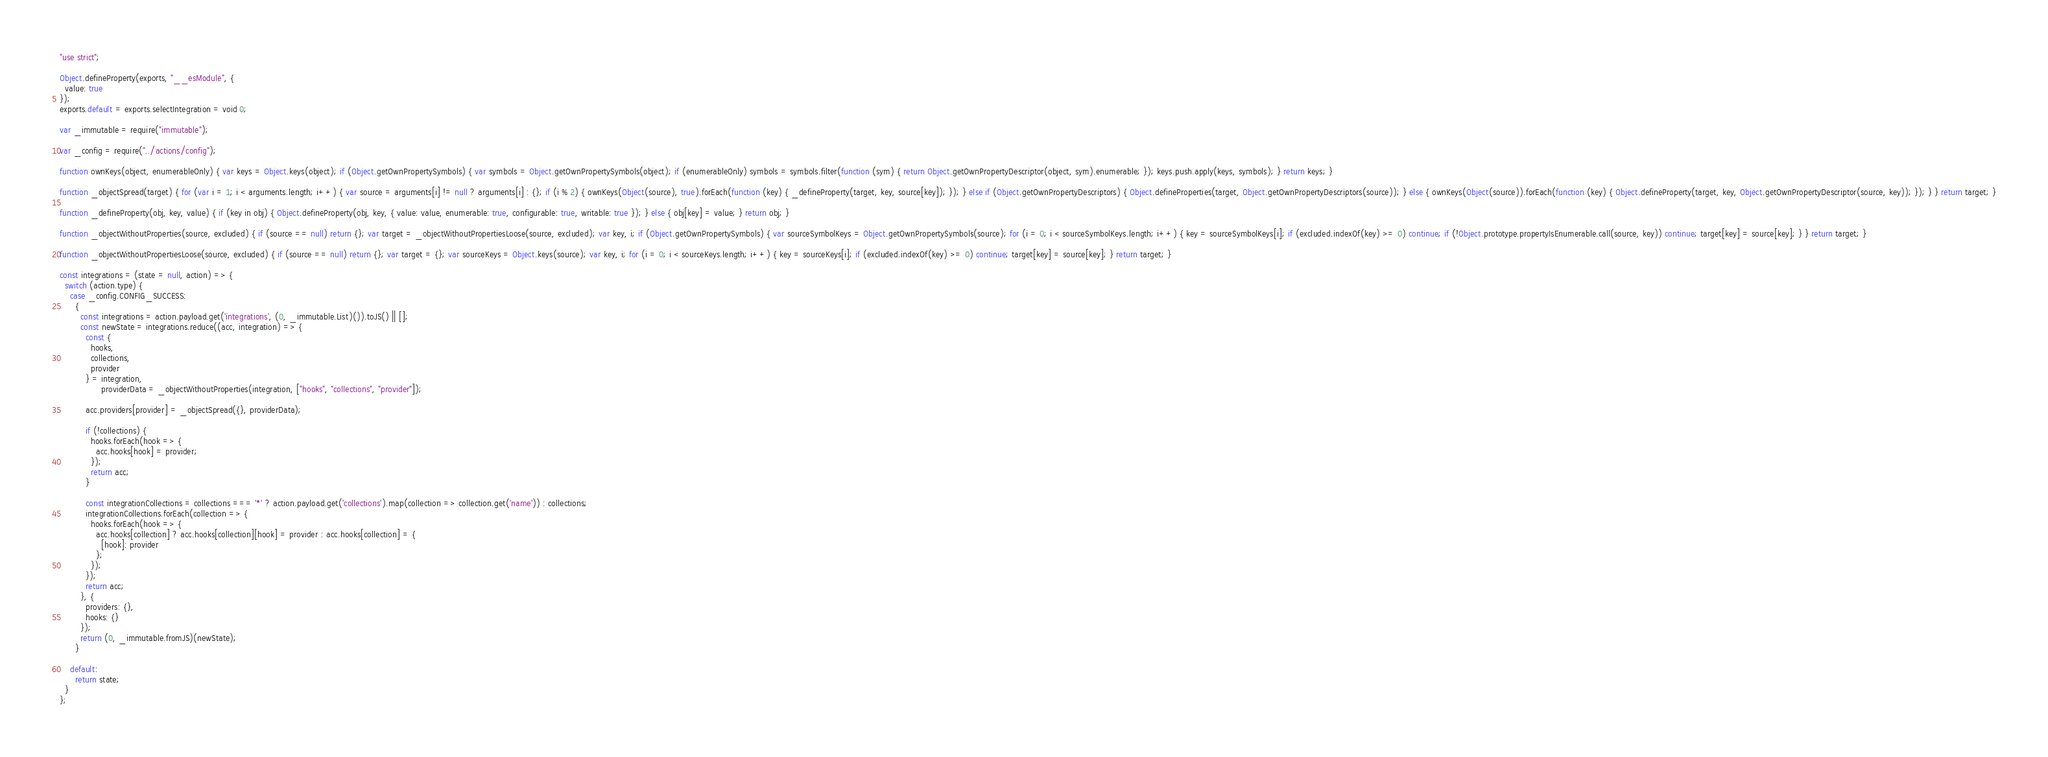<code> <loc_0><loc_0><loc_500><loc_500><_JavaScript_>"use strict";

Object.defineProperty(exports, "__esModule", {
  value: true
});
exports.default = exports.selectIntegration = void 0;

var _immutable = require("immutable");

var _config = require("../actions/config");

function ownKeys(object, enumerableOnly) { var keys = Object.keys(object); if (Object.getOwnPropertySymbols) { var symbols = Object.getOwnPropertySymbols(object); if (enumerableOnly) symbols = symbols.filter(function (sym) { return Object.getOwnPropertyDescriptor(object, sym).enumerable; }); keys.push.apply(keys, symbols); } return keys; }

function _objectSpread(target) { for (var i = 1; i < arguments.length; i++) { var source = arguments[i] != null ? arguments[i] : {}; if (i % 2) { ownKeys(Object(source), true).forEach(function (key) { _defineProperty(target, key, source[key]); }); } else if (Object.getOwnPropertyDescriptors) { Object.defineProperties(target, Object.getOwnPropertyDescriptors(source)); } else { ownKeys(Object(source)).forEach(function (key) { Object.defineProperty(target, key, Object.getOwnPropertyDescriptor(source, key)); }); } } return target; }

function _defineProperty(obj, key, value) { if (key in obj) { Object.defineProperty(obj, key, { value: value, enumerable: true, configurable: true, writable: true }); } else { obj[key] = value; } return obj; }

function _objectWithoutProperties(source, excluded) { if (source == null) return {}; var target = _objectWithoutPropertiesLoose(source, excluded); var key, i; if (Object.getOwnPropertySymbols) { var sourceSymbolKeys = Object.getOwnPropertySymbols(source); for (i = 0; i < sourceSymbolKeys.length; i++) { key = sourceSymbolKeys[i]; if (excluded.indexOf(key) >= 0) continue; if (!Object.prototype.propertyIsEnumerable.call(source, key)) continue; target[key] = source[key]; } } return target; }

function _objectWithoutPropertiesLoose(source, excluded) { if (source == null) return {}; var target = {}; var sourceKeys = Object.keys(source); var key, i; for (i = 0; i < sourceKeys.length; i++) { key = sourceKeys[i]; if (excluded.indexOf(key) >= 0) continue; target[key] = source[key]; } return target; }

const integrations = (state = null, action) => {
  switch (action.type) {
    case _config.CONFIG_SUCCESS:
      {
        const integrations = action.payload.get('integrations', (0, _immutable.List)()).toJS() || [];
        const newState = integrations.reduce((acc, integration) => {
          const {
            hooks,
            collections,
            provider
          } = integration,
                providerData = _objectWithoutProperties(integration, ["hooks", "collections", "provider"]);

          acc.providers[provider] = _objectSpread({}, providerData);

          if (!collections) {
            hooks.forEach(hook => {
              acc.hooks[hook] = provider;
            });
            return acc;
          }

          const integrationCollections = collections === '*' ? action.payload.get('collections').map(collection => collection.get('name')) : collections;
          integrationCollections.forEach(collection => {
            hooks.forEach(hook => {
              acc.hooks[collection] ? acc.hooks[collection][hook] = provider : acc.hooks[collection] = {
                [hook]: provider
              };
            });
          });
          return acc;
        }, {
          providers: {},
          hooks: {}
        });
        return (0, _immutable.fromJS)(newState);
      }

    default:
      return state;
  }
};
</code> 